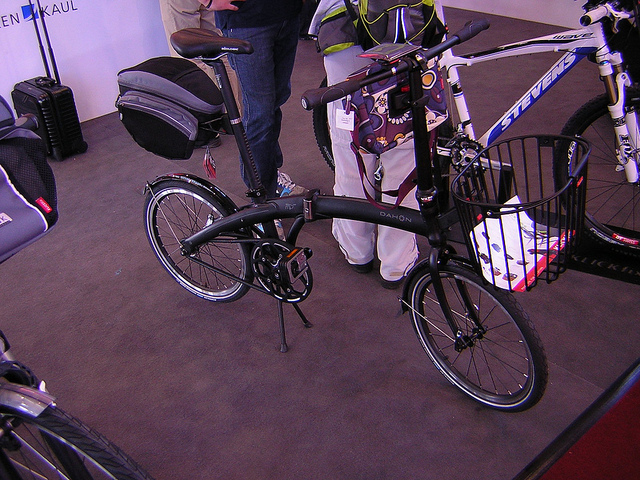Please transcribe the text in this image. KAUL DAHON STEVENS IIIPVA EN 